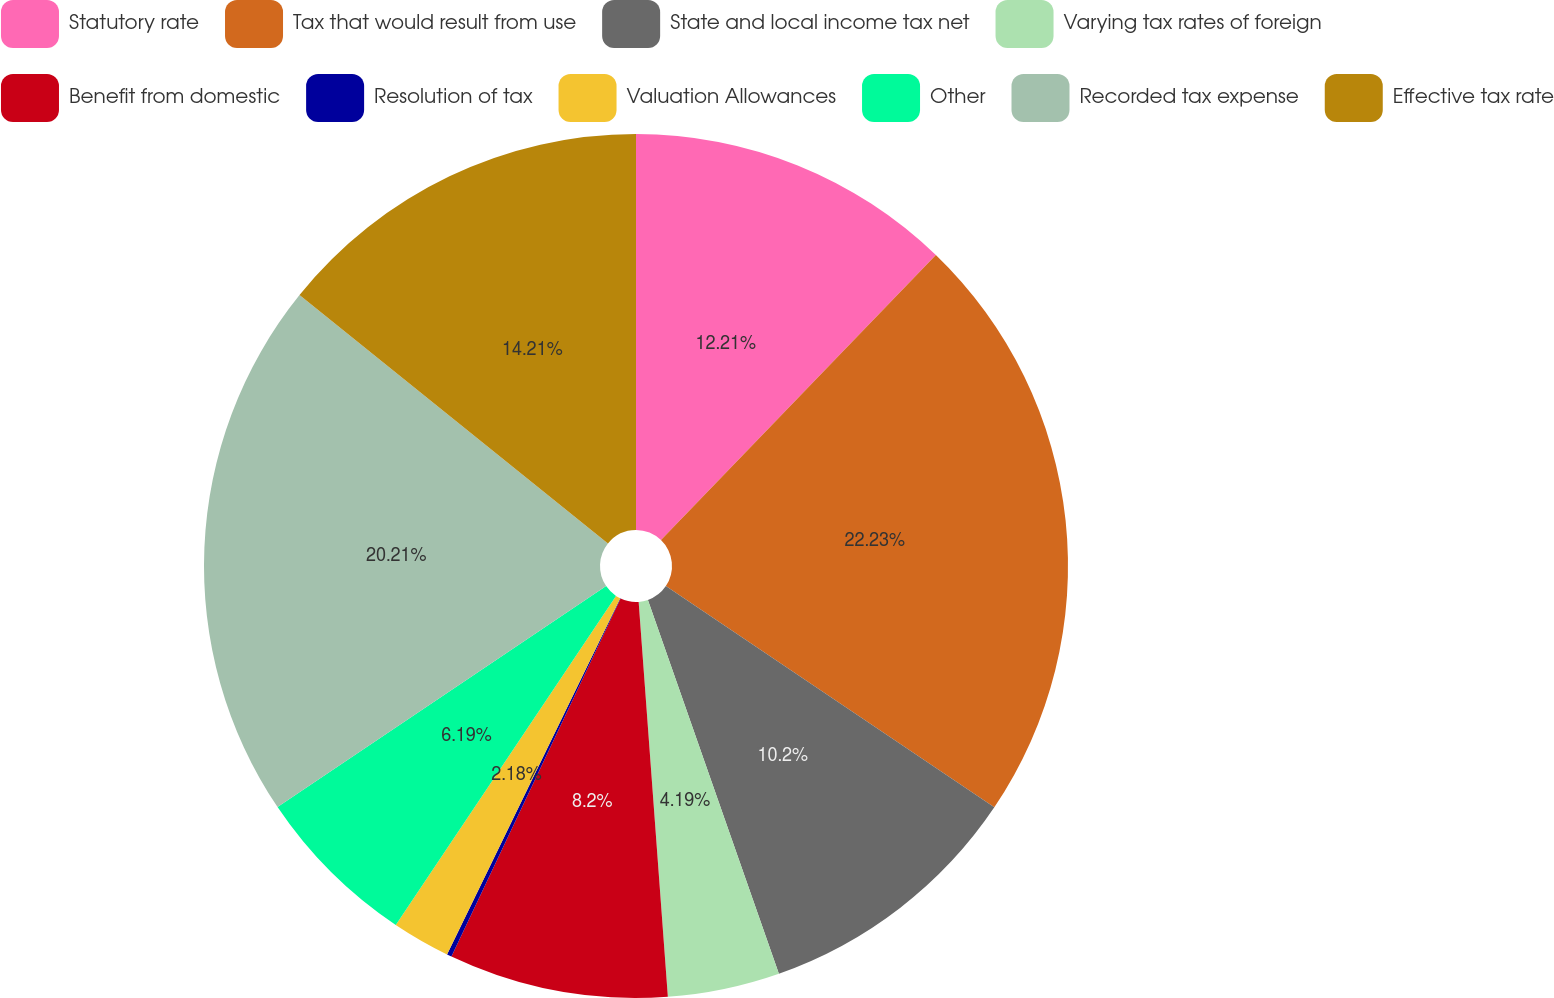<chart> <loc_0><loc_0><loc_500><loc_500><pie_chart><fcel>Statutory rate<fcel>Tax that would result from use<fcel>State and local income tax net<fcel>Varying tax rates of foreign<fcel>Benefit from domestic<fcel>Resolution of tax<fcel>Valuation Allowances<fcel>Other<fcel>Recorded tax expense<fcel>Effective tax rate<nl><fcel>12.21%<fcel>22.22%<fcel>10.2%<fcel>4.19%<fcel>8.2%<fcel>0.18%<fcel>2.18%<fcel>6.19%<fcel>20.21%<fcel>14.21%<nl></chart> 